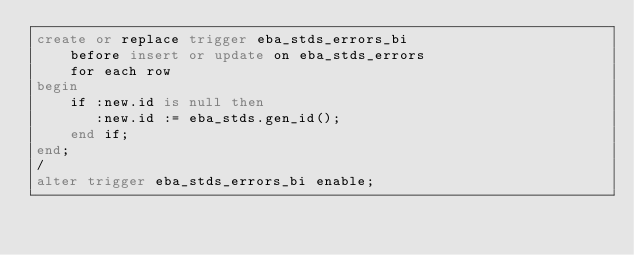Convert code to text. <code><loc_0><loc_0><loc_500><loc_500><_SQL_>create or replace trigger eba_stds_errors_bi
    before insert or update on eba_stds_errors
    for each row
begin
    if :new.id is null then
       :new.id := eba_stds.gen_id();
    end if;
end;
/
alter trigger eba_stds_errors_bi enable;
</code> 